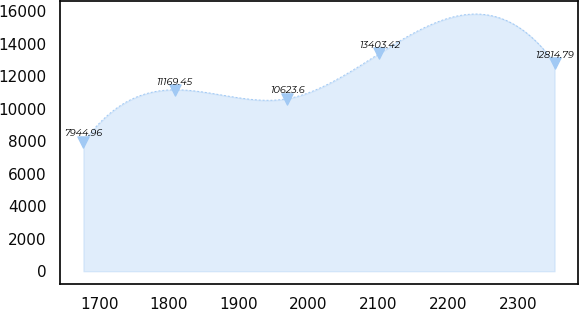<chart> <loc_0><loc_0><loc_500><loc_500><line_chart><ecel><fcel>Unnamed: 1<nl><fcel>1677.38<fcel>7944.96<nl><fcel>1807.96<fcel>11169.5<nl><fcel>1969.84<fcel>10623.6<nl><fcel>2101.58<fcel>13403.4<nl><fcel>2352.62<fcel>12814.8<nl></chart> 